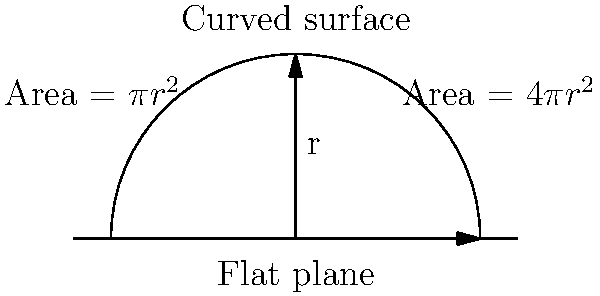As the village head, you're planning to build a new community center. The architect suggests a dome-shaped roof instead of a flat one. If the radius of the base is 10 meters, how much more surface area would the dome-shaped roof have compared to a flat circular roof? Assume the dome is a perfect hemisphere. Let's approach this step-by-step:

1) For a flat circular roof:
   Area = $\pi r^2$
   Area = $\pi \cdot 10^2 = 100\pi$ square meters

2) For a hemispherical dome:
   Surface area of a hemisphere = $2\pi r^2$
   Area = $2\pi \cdot 10^2 = 200\pi$ square meters

3) To find how much more surface area the dome has:
   Difference = Dome area - Flat roof area
               = $200\pi - 100\pi = 100\pi$ square meters

4) To express this as a percentage increase:
   Percentage increase = $\frac{\text{Difference}}{\text{Original}} \times 100\%$
                       = $\frac{100\pi}{100\pi} \times 100\% = 100\%$

Thus, the dome-shaped roof would have 100% more surface area, or twice as much surface area as the flat roof.
Answer: 100% more (or twice the area) 